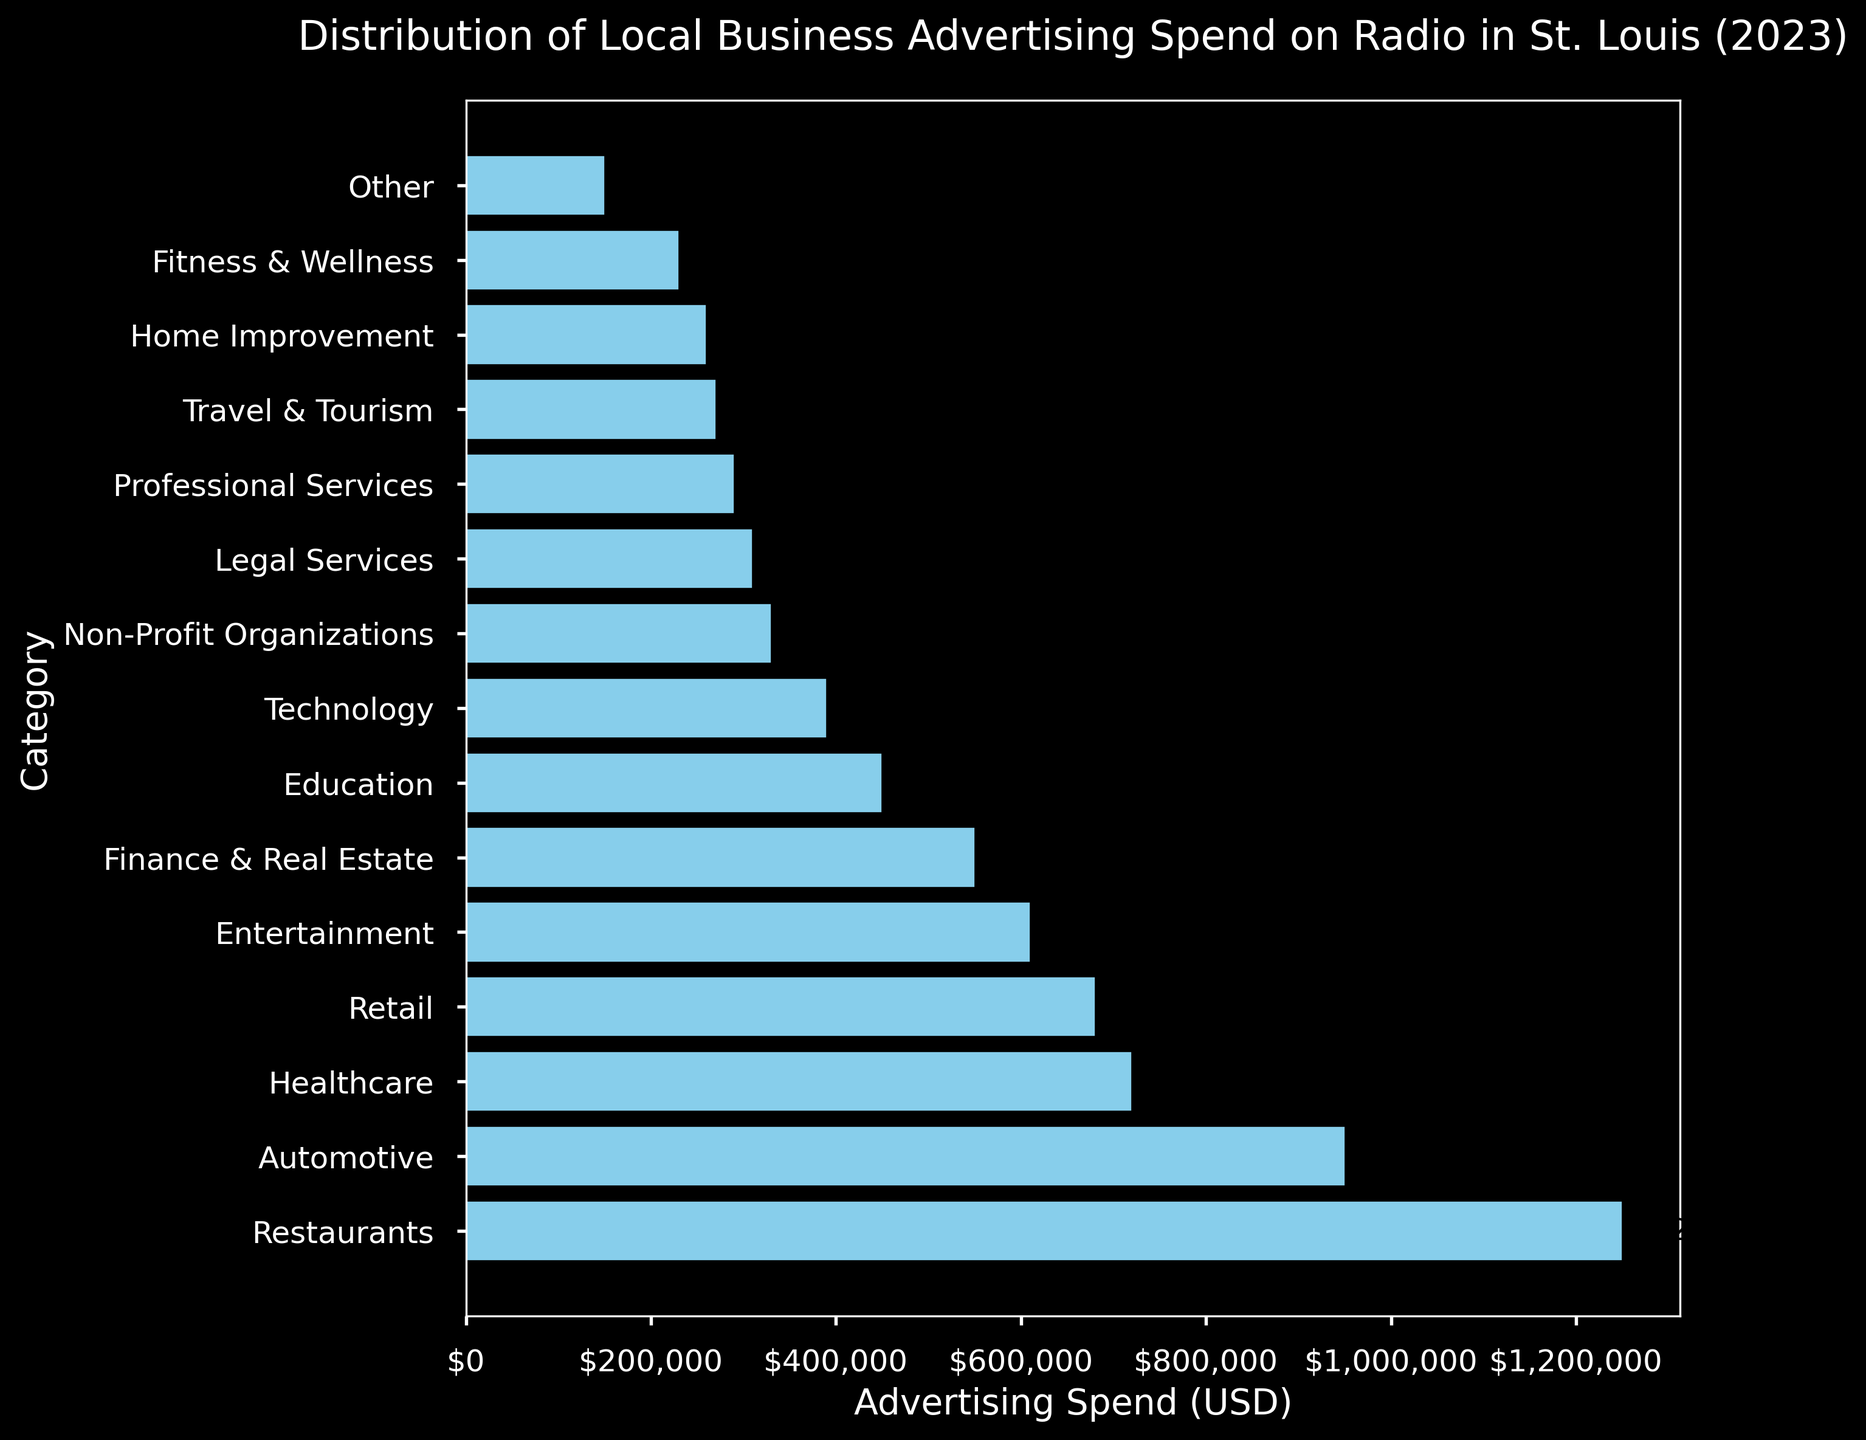Which category has the highest advertising spend? The category with the highest bar length represents the highest advertising spend. According to the figure, Restaurants have the highest advertising spend.
Answer: Restaurants What is the total advertising spend for Healthcare and Entertainment combined? Add the Healthcare advertising spend ($720,000) to the Entertainment advertising spend ($610,000). $720,000 + $610,000 = $1,330,000
Answer: $1,330,000 By how much does the advertising spend of Restaurants exceed Automotive? Subtract the Automotive advertising spend ($950,000) from the Restaurants advertising spend ($1,250,000). $1,250,000 - $950,000 = $300,000
Answer: $300,000 Which category spends less on advertising: Education or Technology? Compare the bar lengths for Education and Technology. Education has an advertising spend of $450,000 while Technology has $390,000. Technology spends less.
Answer: Technology How much greater is the advertising spend of Legal Services compared to Professional Services? Subtract the Professional Services advertising spend ($290,000) from the Legal Services advertising spend ($310,000). $310,000 - $290,000 = $20,000
Answer: $20,000 What is the combined advertising spend of the top three categories? Add the advertising spend of the top three categories: Restaurants ($1,250,000), Automotive ($950,000), and Healthcare ($720,000). $1,250,000 + $950,000 + $720,000 = $2,920,000
Answer: $2,920,000 Which category has the smallest advertising spend, and what is the value? The shortest bar on the plot represents the smallest advertising spend. The 'Other' category has the smallest advertising spend at $150,000.
Answer: Other, $150,000 How does the advertising spend of Finance & Real Estate compare to Retail? Compare the bar lengths for Finance & Real Estate and Retail. Finance & Real Estate spends $550,000, while Retail spends $680,000. Retail spends more than Finance & Real Estate.
Answer: Retail spends more What is the advertising spend difference between Fitness & Wellness and Home Improvement? Subtract the advertising spend of Home Improvement ($260,000) from Fitness & Wellness ($230,000). $230,000 - $260,000 = -$30,000. Fitness & Wellness spends $30,000 less than Home Improvement.
Answer: $30,000 less What percentage of the total advertising spend is attributed to Non-Profit Organizations? First, sum the total advertising spend for all categories. The total is $6,780,000. Then, divide the Non-Profit Organizations advertising spend ($330,000) by this total and multiply by 100 to get the percentage. ($330,000 / $6,780,000) * 100 ≈ 4.87%
Answer: 4.87% 